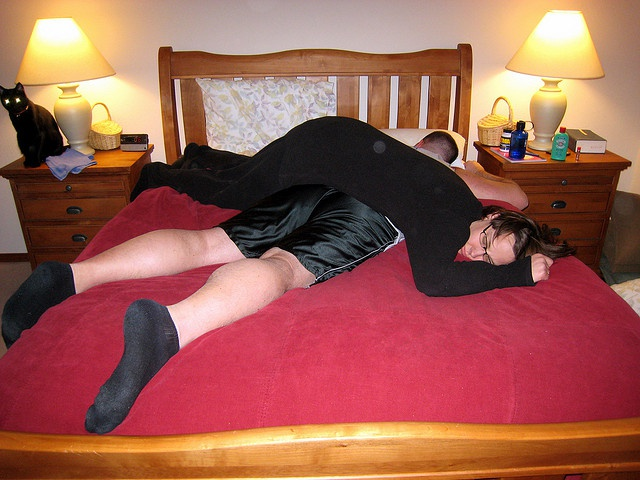Describe the objects in this image and their specific colors. I can see bed in gray and brown tones, people in gray, black, lightpink, and pink tones, people in gray, black, lightpink, maroon, and brown tones, cat in gray, black, maroon, olive, and brown tones, and book in brown, tan, gray, and maroon tones in this image. 